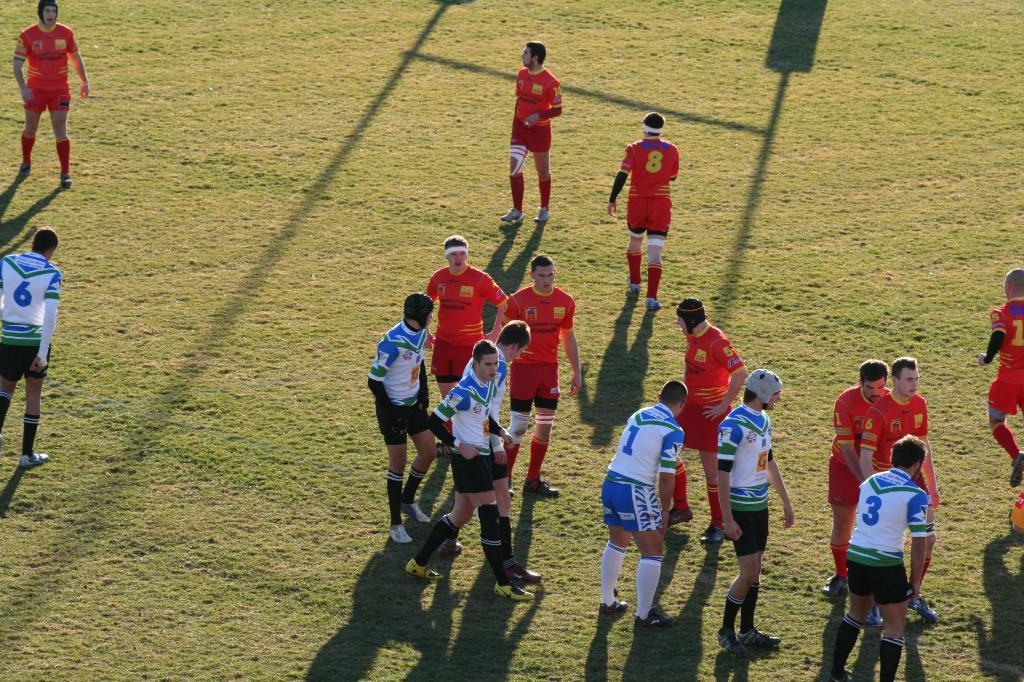<image>
Offer a succinct explanation of the picture presented. A group of rugby players in white and blue, and red. There are jerseys with the numbers 1, 3, and 6 